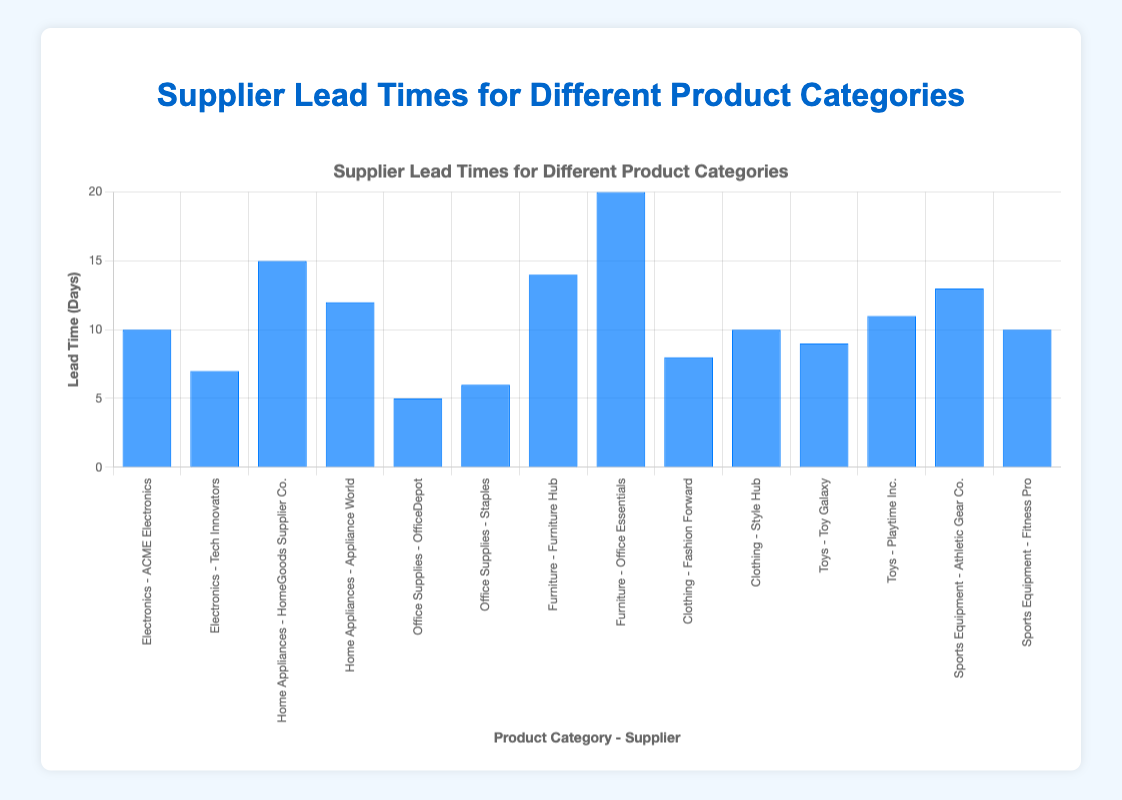Which supplier has the shortest lead time for Office Supplies? We look at the lead times for "Office Supplies" category, which are 5 days for "OfficeDepot" and 6 days for "Staples". The shortest lead time is 5 days by "OfficeDepot".
Answer: OfficeDepot What is the difference in lead times between the suppliers "Furniture Hub" and "Office Essentials" in the Furniture category? We find the lead times for "Furniture Hub" (14 days) and "Office Essentials" (20 days). The difference is 20 - 14 = 6 days.
Answer: 6 days Which product category has the highest average lead time? We calculate the average lead time for each category: 
1. Electronics: (10 + 7) / 2 = 8.5 days
2. Home Appliances: (15 + 12) / 2 = 13.5 days
3. Office Supplies: (5 + 6) / 2 = 5.5 days
4. Furniture: (14 + 20) / 2 = 17 days
5. Clothing: (8 + 10) / 2 = 9 days
6. Toys: (9 + 11) / 2 = 10 days
7. Sports Equipment: (13 + 10) / 2 = 11.5 days
The highest average lead time is in the Furniture category with 17 days.
Answer: Furniture What is the total lead time for both suppliers in the Toys category? The lead times for "Toy Galaxy" and "Playtime Inc." are 9 and 11 days, respectively. Their total lead time is 9 + 11 = 20 days.
Answer: 20 days Are there any suppliers with the same lead time within the same product category? We check the lead times within each product category to see if any match. No matching lead times were found within the same category. Each supplier has a unique lead time.
Answer: No 